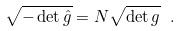<formula> <loc_0><loc_0><loc_500><loc_500>\sqrt { - \det \hat { g } } = N \sqrt { \det g } \ .</formula> 